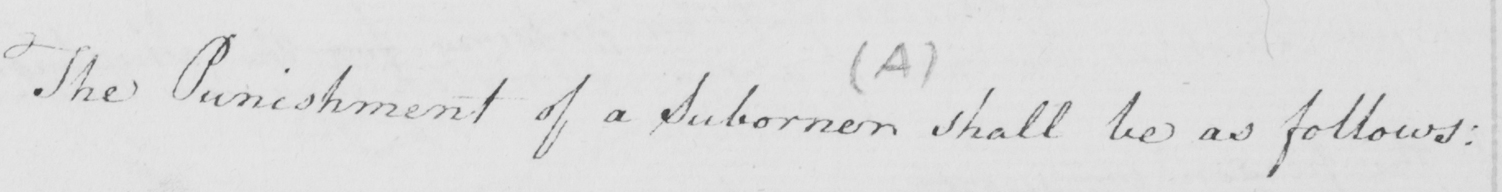Please provide the text content of this handwritten line. The Punishment of a Suborner shall be as follows : 